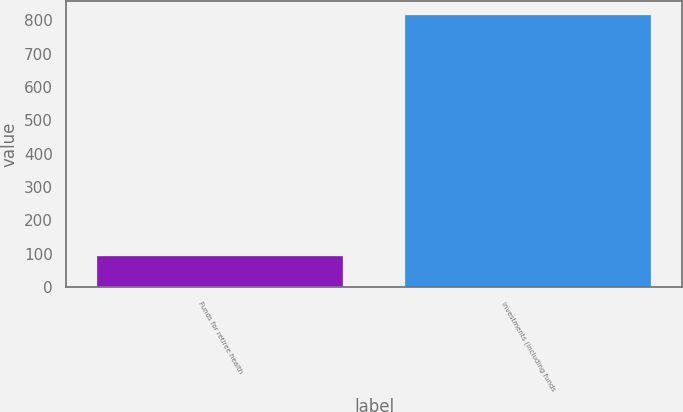<chart> <loc_0><loc_0><loc_500><loc_500><bar_chart><fcel>Funds for retiree health<fcel>Investments (including funds<nl><fcel>94<fcel>816<nl></chart> 